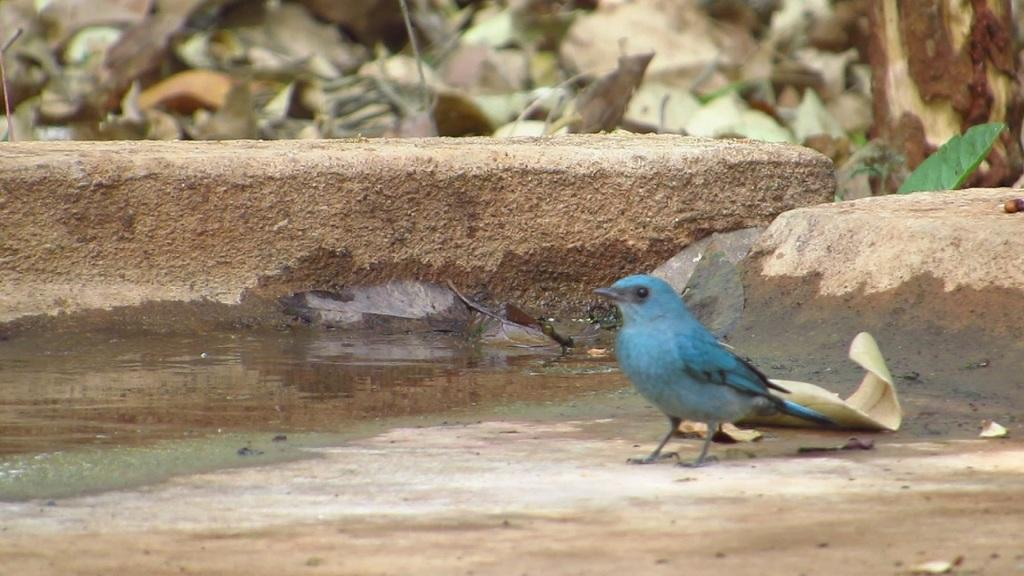What type of animal is in the image? There is a bird in the image. What color is the bird? The bird is green in color. What can be seen in the background of the image? There are dried leaves and water visible in the background of the image. How many pizzas are floating in the swimming pool water in the image? There are no pizzas present in the image, and the swimming pool water is not visible in the image. 